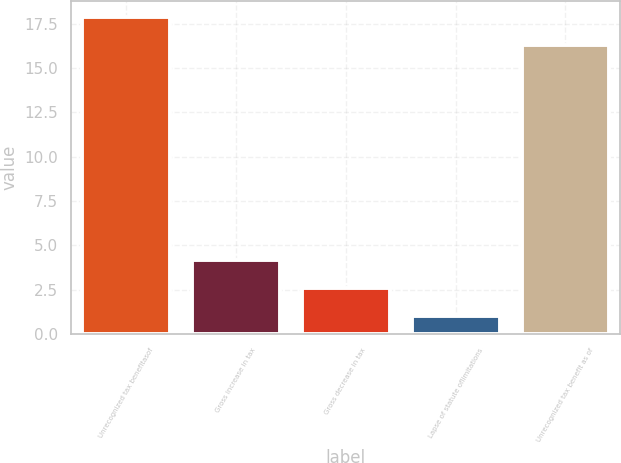<chart> <loc_0><loc_0><loc_500><loc_500><bar_chart><fcel>Unrecognized tax benefitasof<fcel>Gross increase in tax<fcel>Gross decrease in tax<fcel>Lapse of statute oflimitations<fcel>Unrecognized tax benefit as of<nl><fcel>17.88<fcel>4.16<fcel>2.58<fcel>1<fcel>16.3<nl></chart> 